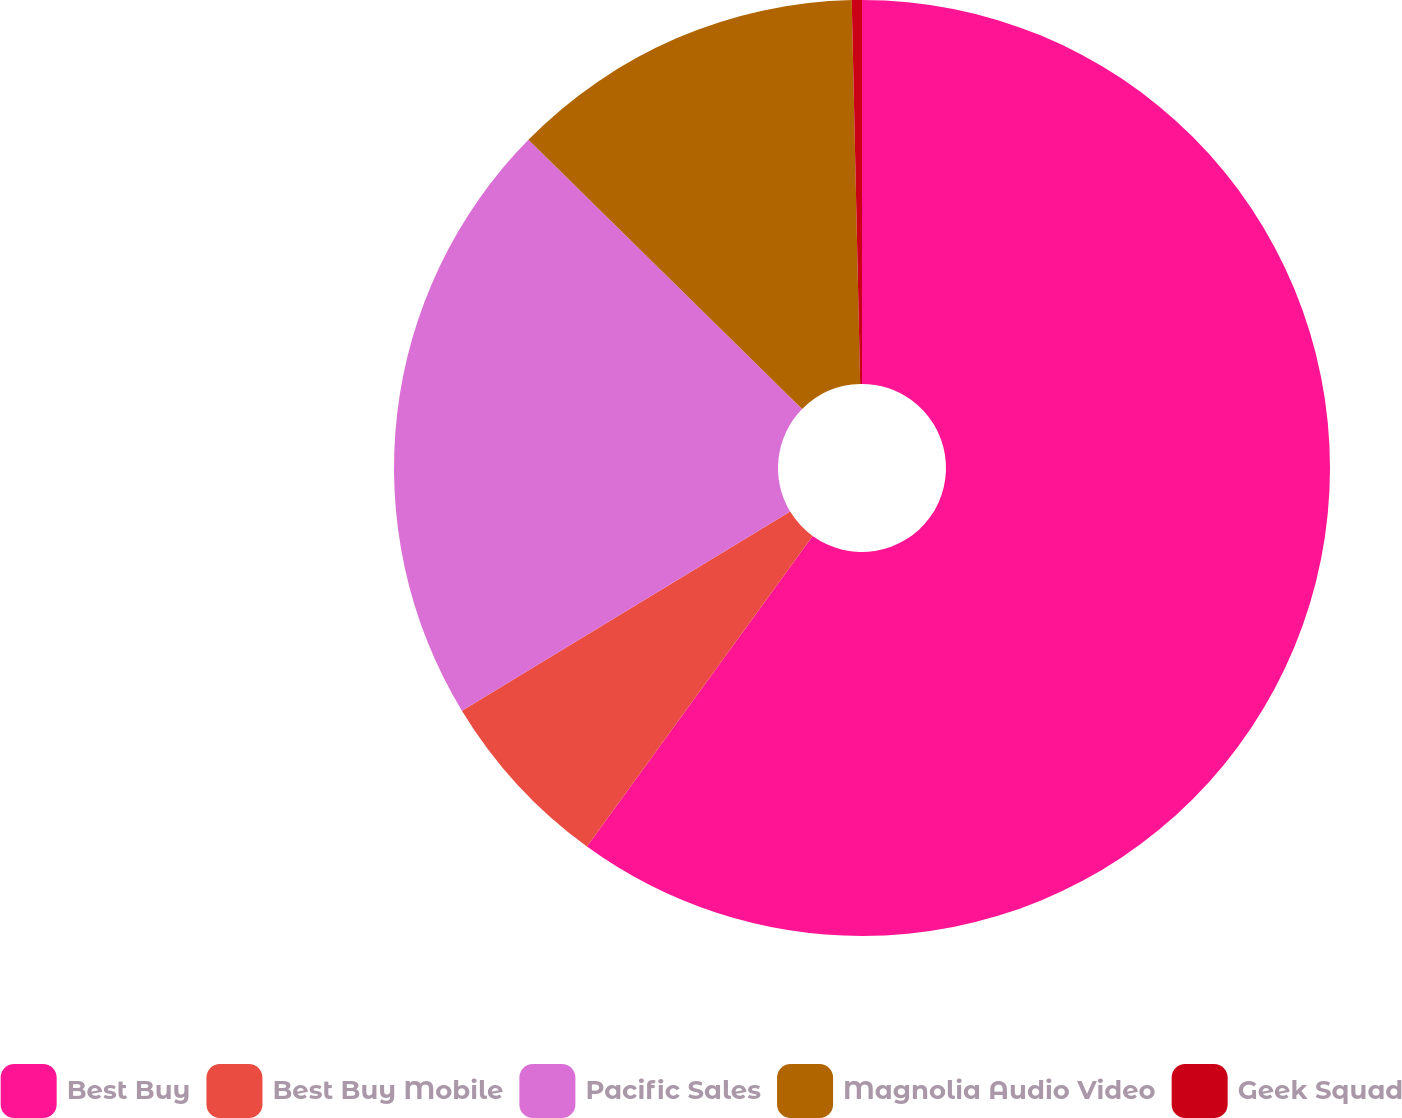<chart> <loc_0><loc_0><loc_500><loc_500><pie_chart><fcel>Best Buy<fcel>Best Buy Mobile<fcel>Pacific Sales<fcel>Magnolia Audio Video<fcel>Geek Squad<nl><fcel>60.0%<fcel>6.32%<fcel>21.05%<fcel>12.28%<fcel>0.35%<nl></chart> 